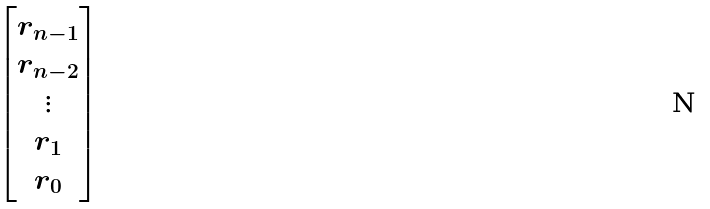Convert formula to latex. <formula><loc_0><loc_0><loc_500><loc_500>\begin{bmatrix} r _ { n - 1 } \\ r _ { n - 2 } \\ \vdots \\ r _ { 1 } \\ r _ { 0 } \end{bmatrix}</formula> 